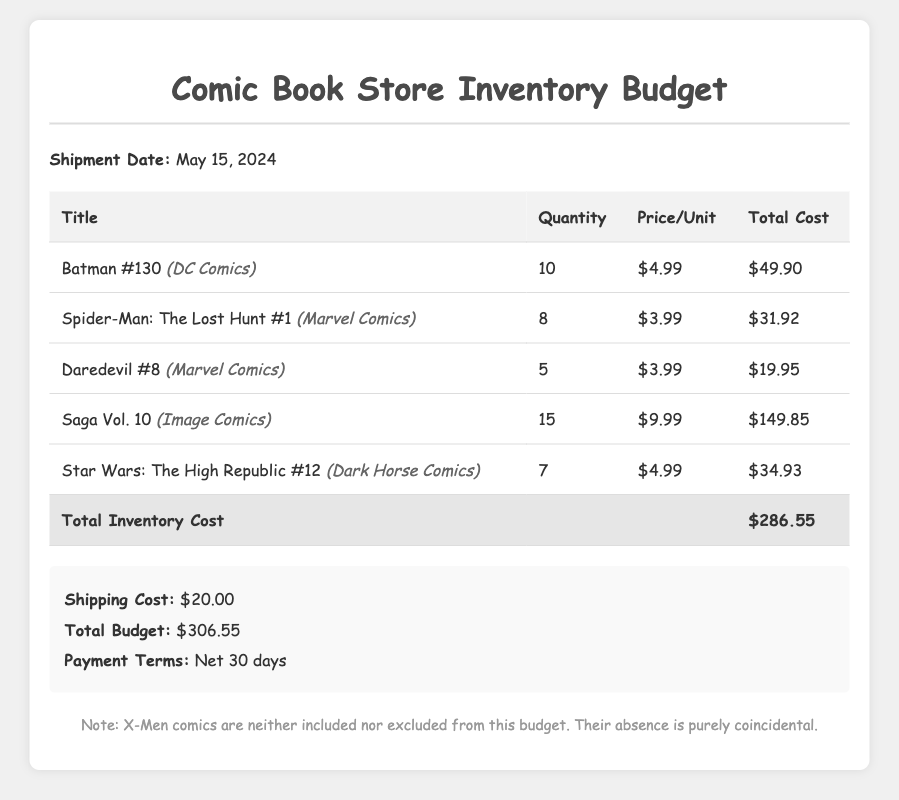What is the shipment date? The shipment date is explicitly mentioned in the document.
Answer: May 15, 2024 How many copies of Saga Vol. 10 are being ordered? The number of copies for each title is listed in the quantity column of the table.
Answer: 15 What is the price per unit for Batman #130? The price per unit is provided in the pricing column of the table.
Answer: $4.99 What is the total cost for Spider-Man: The Lost Hunt #1? The total cost is calculated as quantity times price per unit for each title in the table.
Answer: $31.92 What is the total inventory cost? The total inventory cost is summarized at the bottom of the table in the total row.
Answer: $286.55 What is the shipping cost? The shipping cost is detailed specifically in the summary section.
Answer: $20.00 What are the payment terms? The payment terms are stated in the summary section of the document.
Answer: Net 30 days How many total titles are listed in the inventory budget? The total number of titles can be counted from each row in the table.
Answer: 5 Is there any mention of X-Men comics in the budget? The document explicitly mentions X-Men comics in the note, indicating their absence.
Answer: No 